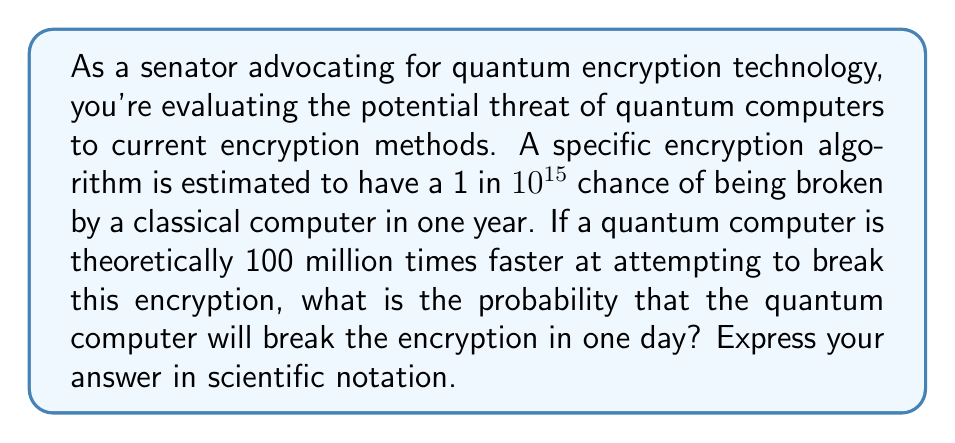Can you solve this math problem? To solve this problem, let's break it down into steps:

1) First, let's calculate the probability of breaking the encryption in one day using a classical computer:
   $$P(\text{classical, 1 day}) = \frac{1}{10^{15}} \cdot \frac{1}{365} = \frac{1}{3.65 \times 10^{17}}$$

2) Now, we need to account for the quantum computer's speed advantage:
   $$\text{Speed factor} = 100,000,000 = 10^8$$

3) The probability of the quantum computer breaking the encryption in one day is the classical probability multiplied by the speed factor:
   $$P(\text{quantum, 1 day}) = \frac{1}{3.65 \times 10^{17}} \cdot 10^8 = \frac{10^8}{3.65 \times 10^{17}}$$

4) Simplify:
   $$P(\text{quantum, 1 day}) = \frac{1}{3.65 \times 10^9} \approx 2.74 \times 10^{-10}$$

5) Round to two significant figures:
   $$P(\text{quantum, 1 day}) \approx 2.7 \times 10^{-10}$$
Answer: $2.7 \times 10^{-10}$ 